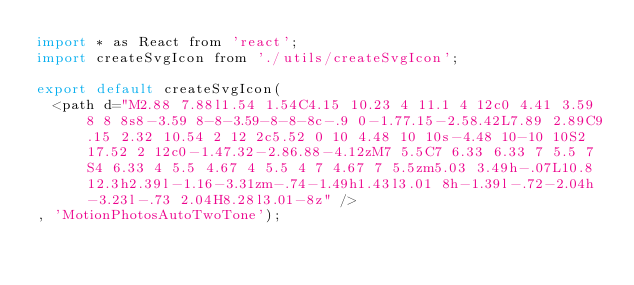<code> <loc_0><loc_0><loc_500><loc_500><_JavaScript_>import * as React from 'react';
import createSvgIcon from './utils/createSvgIcon';

export default createSvgIcon(
  <path d="M2.88 7.88l1.54 1.54C4.15 10.23 4 11.1 4 12c0 4.41 3.59 8 8 8s8-3.59 8-8-3.59-8-8-8c-.9 0-1.77.15-2.58.42L7.89 2.89C9.15 2.32 10.54 2 12 2c5.52 0 10 4.48 10 10s-4.48 10-10 10S2 17.52 2 12c0-1.47.32-2.86.88-4.12zM7 5.5C7 6.33 6.33 7 5.5 7S4 6.33 4 5.5 4.67 4 5.5 4 7 4.67 7 5.5zm5.03 3.49h-.07L10.8 12.3h2.39l-1.16-3.31zm-.74-1.49h1.43l3.01 8h-1.39l-.72-2.04h-3.23l-.73 2.04H8.28l3.01-8z" />
, 'MotionPhotosAutoTwoTone');
</code> 